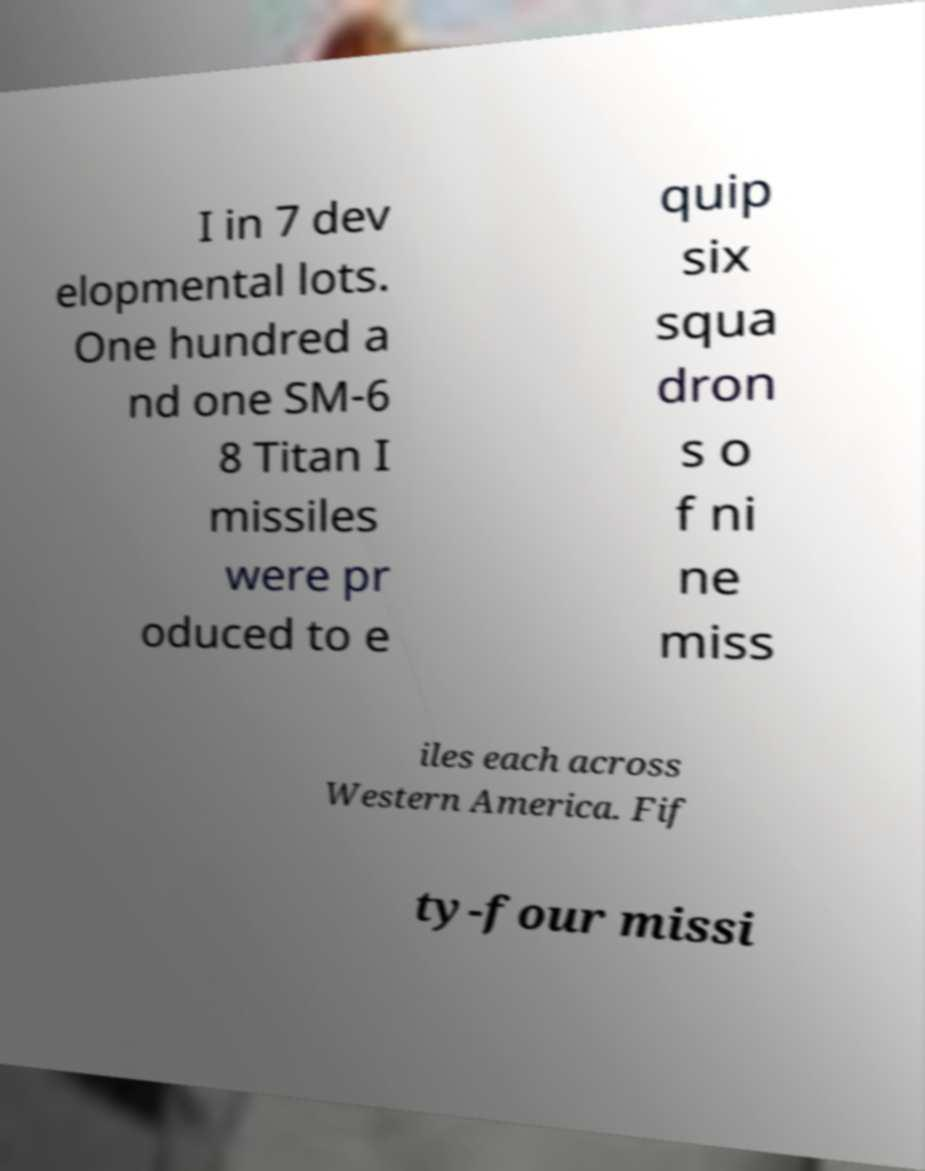Could you extract and type out the text from this image? I in 7 dev elopmental lots. One hundred a nd one SM-6 8 Titan I missiles were pr oduced to e quip six squa dron s o f ni ne miss iles each across Western America. Fif ty-four missi 